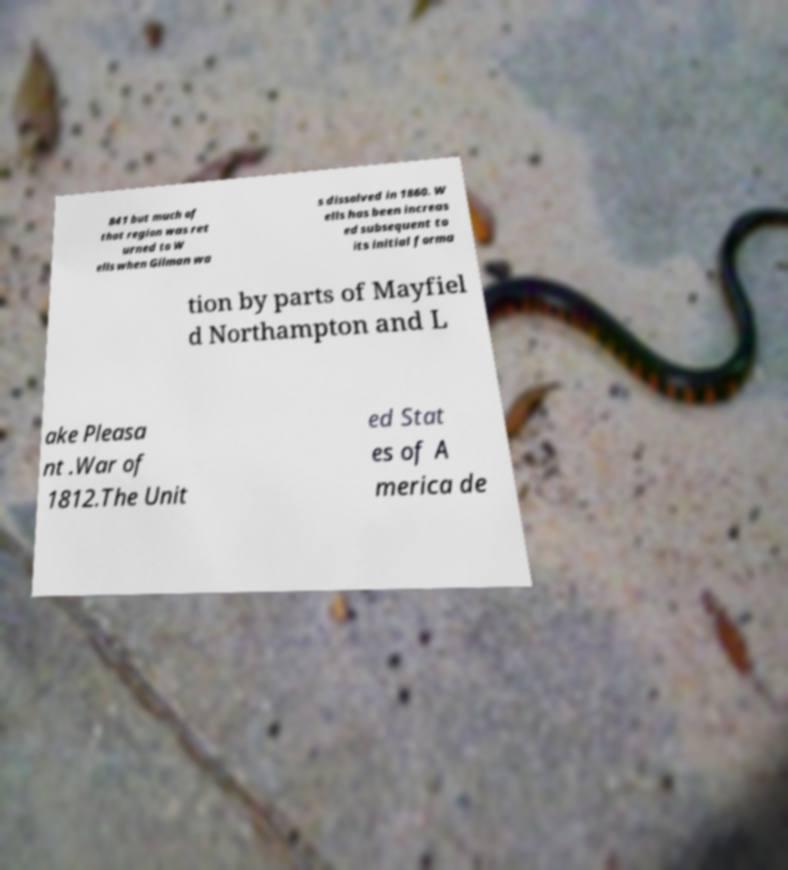Please read and relay the text visible in this image. What does it say? 841 but much of that region was ret urned to W ells when Gilman wa s dissolved in 1860. W ells has been increas ed subsequent to its initial forma tion by parts of Mayfiel d Northampton and L ake Pleasa nt .War of 1812.The Unit ed Stat es of A merica de 